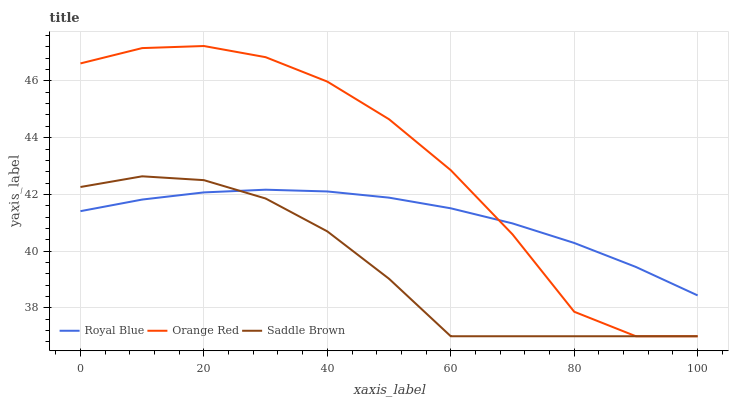Does Orange Red have the minimum area under the curve?
Answer yes or no. No. Does Saddle Brown have the maximum area under the curve?
Answer yes or no. No. Is Saddle Brown the smoothest?
Answer yes or no. No. Is Saddle Brown the roughest?
Answer yes or no. No. Does Saddle Brown have the highest value?
Answer yes or no. No. 